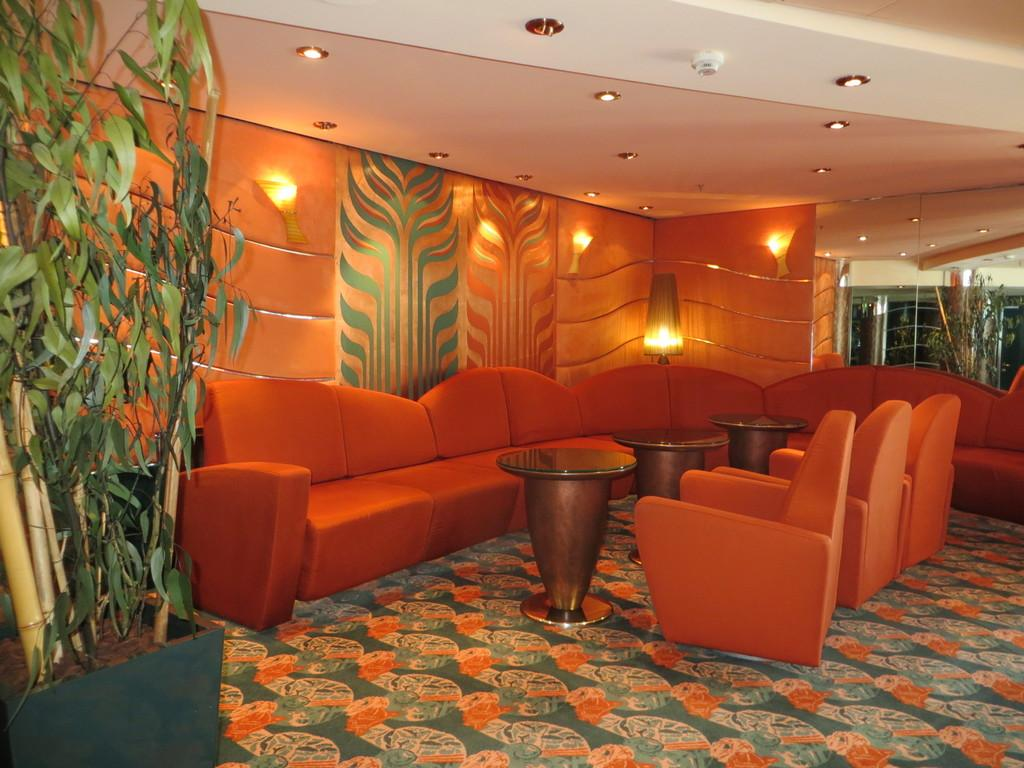What type of furniture is present in the room? There are sofas, tables, and chairs in the room. What other objects can be seen in the room? There are trees and pots in the room. Can you describe the lighting in the room? There is a light behind the sofa, and the background of the image is full of light. What is the weight of the copy on the hospital bed in the image? There is no hospital bed or copy present in the image. 